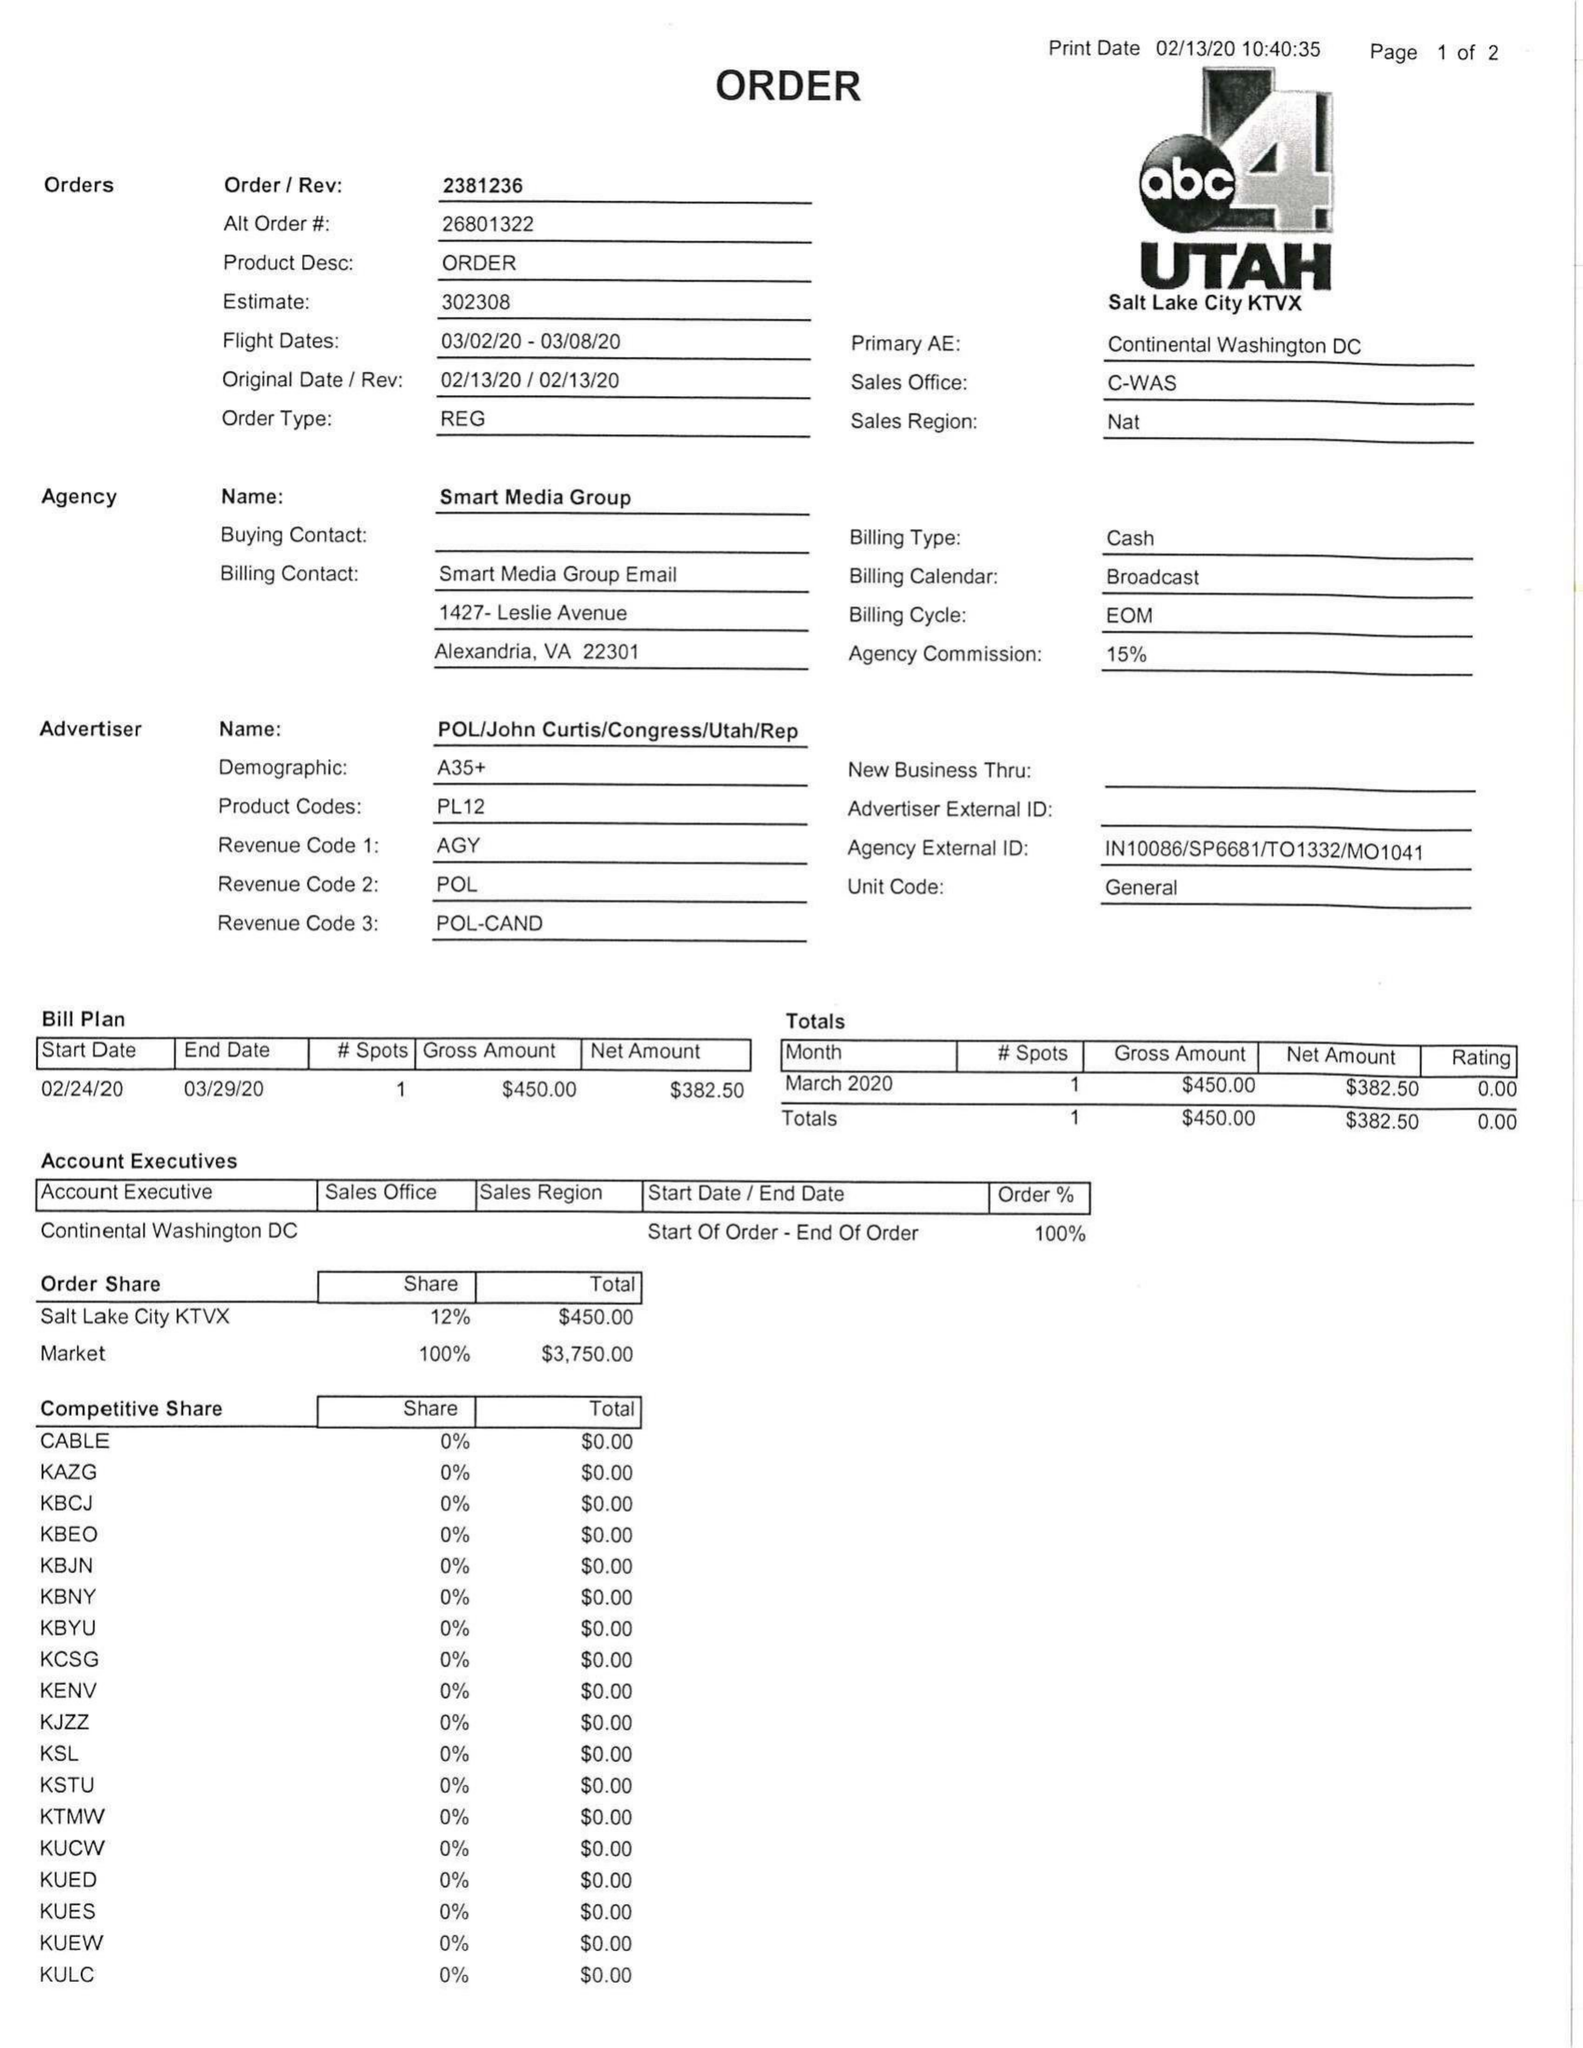What is the value for the contract_num?
Answer the question using a single word or phrase. 2381236 